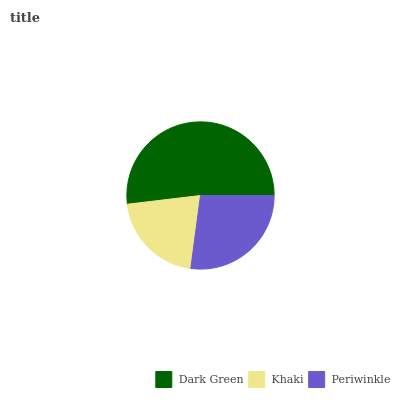Is Khaki the minimum?
Answer yes or no. Yes. Is Dark Green the maximum?
Answer yes or no. Yes. Is Periwinkle the minimum?
Answer yes or no. No. Is Periwinkle the maximum?
Answer yes or no. No. Is Periwinkle greater than Khaki?
Answer yes or no. Yes. Is Khaki less than Periwinkle?
Answer yes or no. Yes. Is Khaki greater than Periwinkle?
Answer yes or no. No. Is Periwinkle less than Khaki?
Answer yes or no. No. Is Periwinkle the high median?
Answer yes or no. Yes. Is Periwinkle the low median?
Answer yes or no. Yes. Is Khaki the high median?
Answer yes or no. No. Is Dark Green the low median?
Answer yes or no. No. 